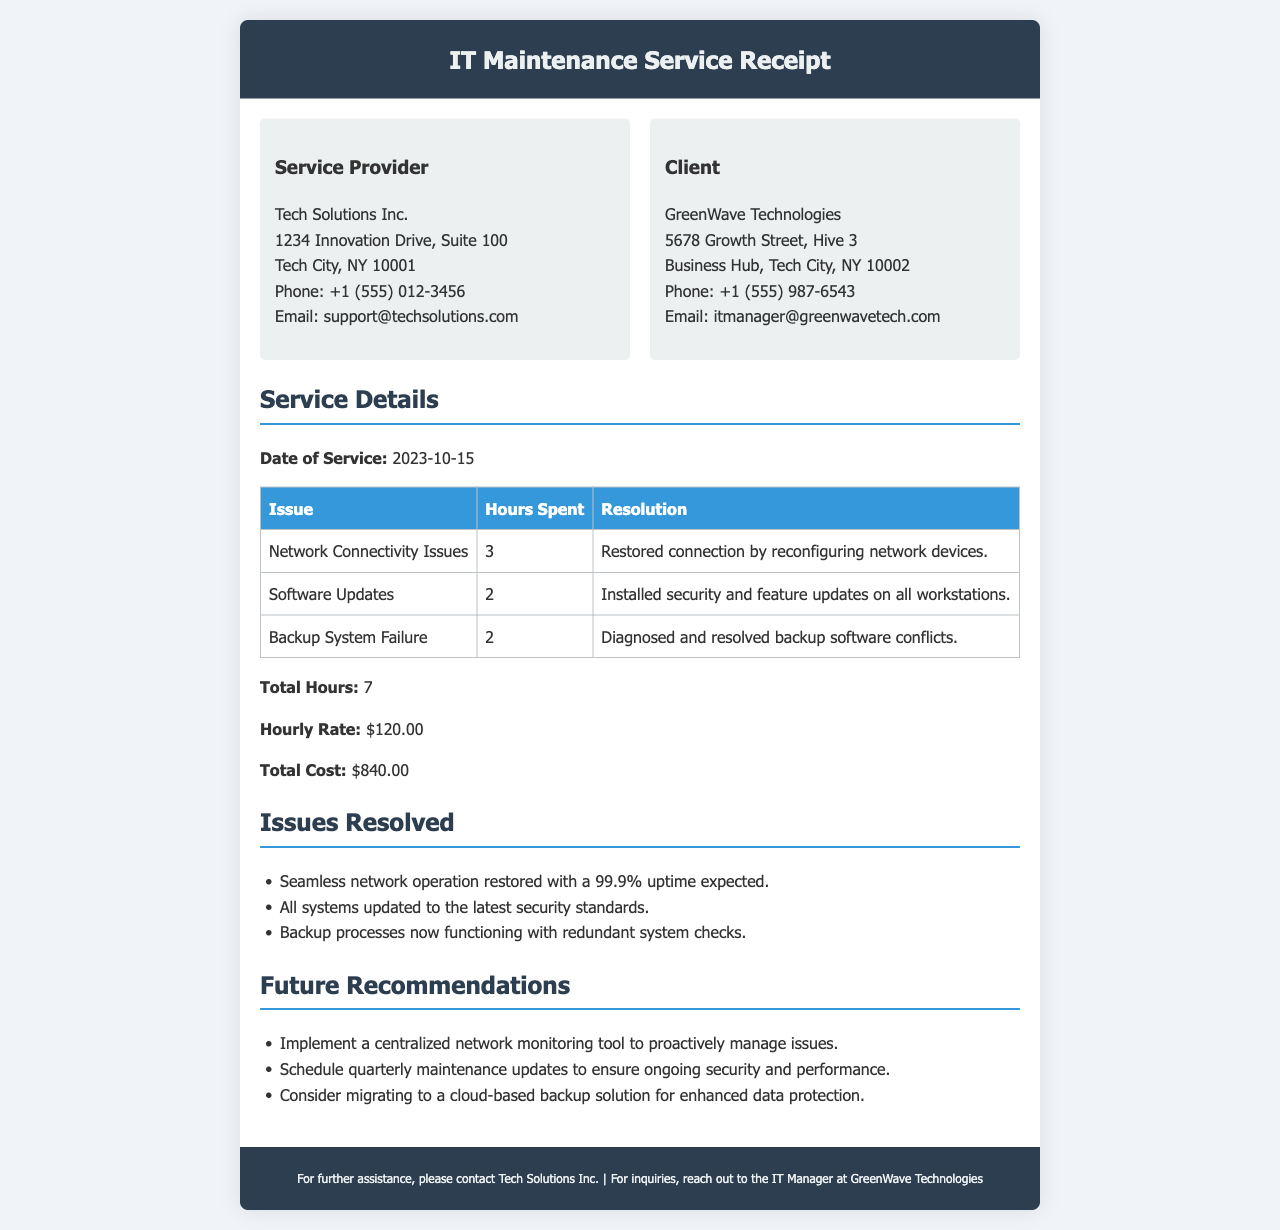what is the name of the service provider? The service provider's name is located in the 'Service Provider' section of the document.
Answer: Tech Solutions Inc what is the date of service? The date of service is specified in the 'Service Details' section.
Answer: 2023-10-15 how many hours were spent on Software Updates? The hours spent on Software Updates can be found in the table under 'Service Details'.
Answer: 2 what is the hourly rate for the services provided? The hourly rate is mentioned in the 'Service Details' section.
Answer: $120.00 what is the total cost for the services rendered? The total cost can be found in the 'Service Details' section at the end of the calculations.
Answer: $840.00 what issue involved a backup system failure? This information is specified in the table under 'Service Details'.
Answer: Backup System Failure what is one of the future recommendations? Future recommendations are listed in their own section, suggesting actions for improvement.
Answer: Implement a centralized network monitoring tool how many total hours were worked on the maintenance service? Total hours worked is calculated and displayed in 'Service Details'.
Answer: 7 what was done to restore the network connectivity? The resolution for the network connectivity issues is provided in the table under 'Service Details'.
Answer: Reconfiguring network devices 